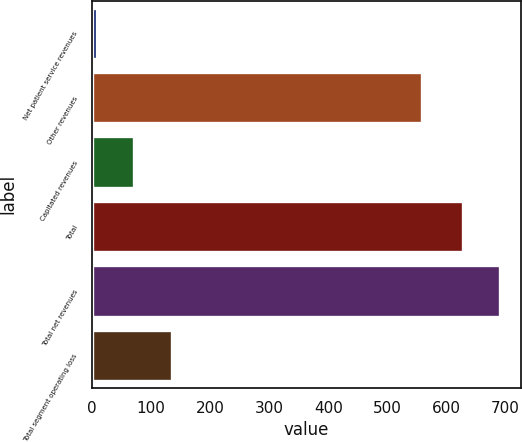Convert chart to OTSL. <chart><loc_0><loc_0><loc_500><loc_500><bar_chart><fcel>Net patient service revenues<fcel>Other revenues<fcel>Capitated revenues<fcel>Total<fcel>Total net revenues<fcel>Total segment operating loss<nl><fcel>8<fcel>558<fcel>71.4<fcel>628<fcel>691.4<fcel>134.8<nl></chart> 